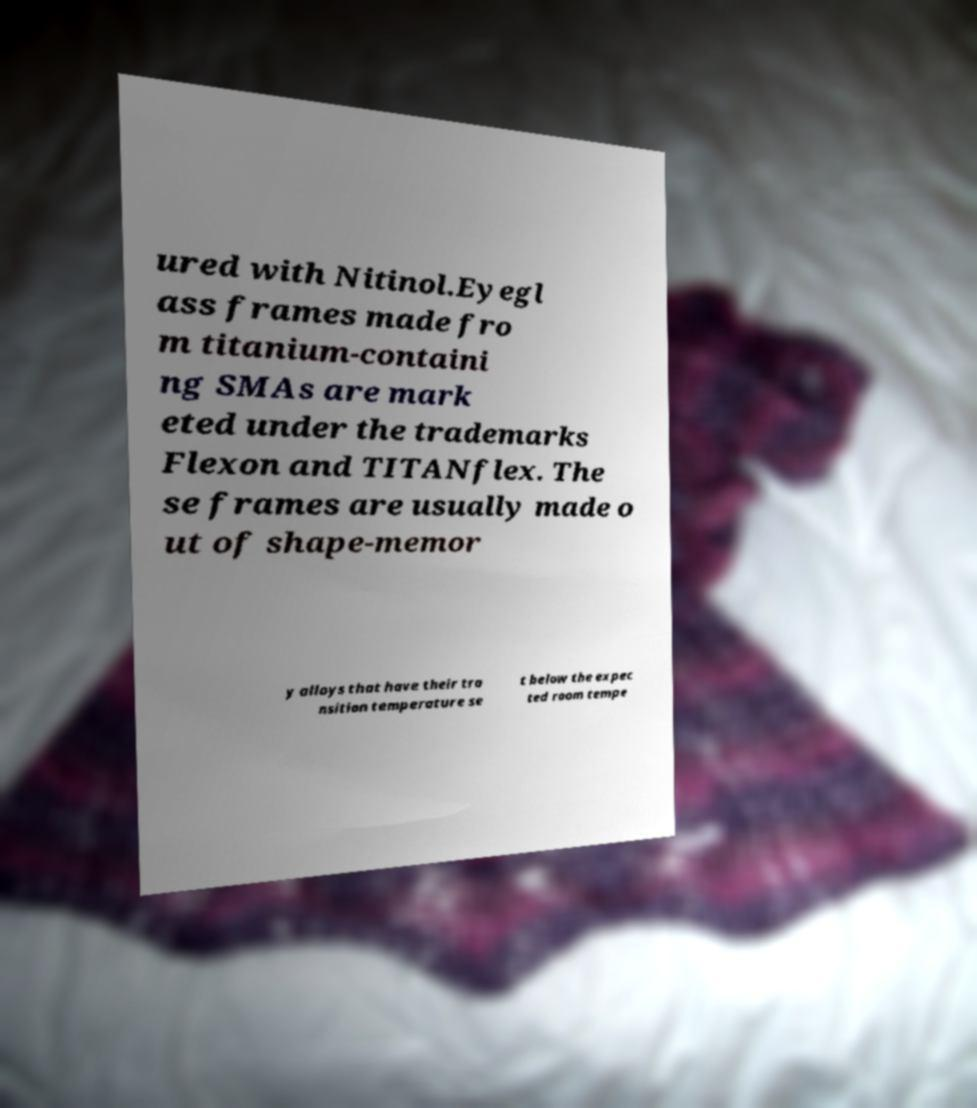Can you read and provide the text displayed in the image?This photo seems to have some interesting text. Can you extract and type it out for me? ured with Nitinol.Eyegl ass frames made fro m titanium-containi ng SMAs are mark eted under the trademarks Flexon and TITANflex. The se frames are usually made o ut of shape-memor y alloys that have their tra nsition temperature se t below the expec ted room tempe 